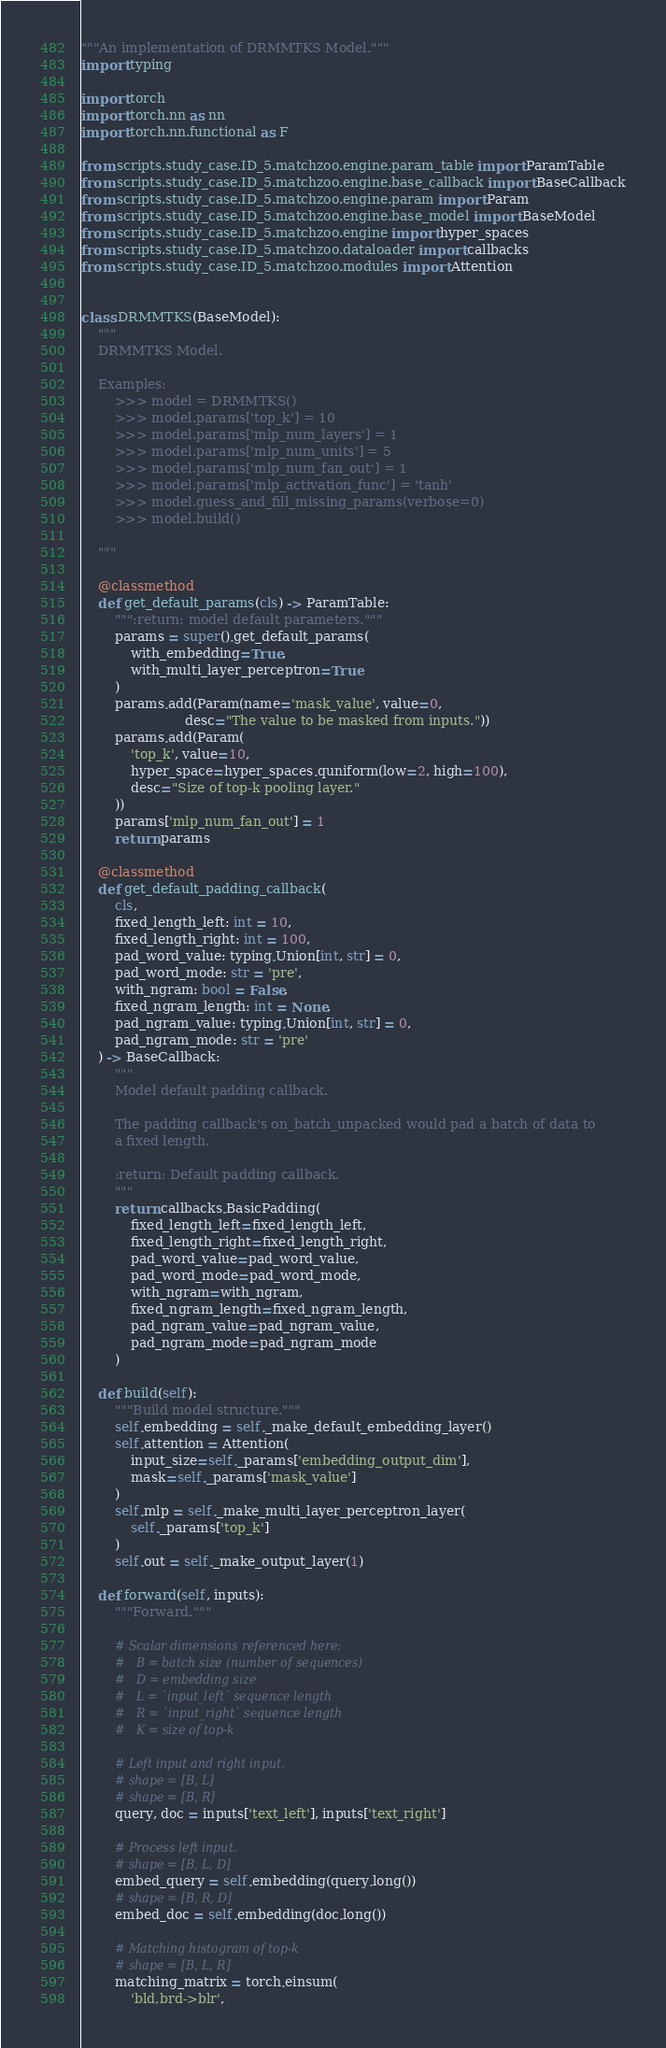Convert code to text. <code><loc_0><loc_0><loc_500><loc_500><_Python_>"""An implementation of DRMMTKS Model."""
import typing

import torch
import torch.nn as nn
import torch.nn.functional as F

from scripts.study_case.ID_5.matchzoo.engine.param_table import ParamTable
from scripts.study_case.ID_5.matchzoo.engine.base_callback import BaseCallback
from scripts.study_case.ID_5.matchzoo.engine.param import Param
from scripts.study_case.ID_5.matchzoo.engine.base_model import BaseModel
from scripts.study_case.ID_5.matchzoo.engine import hyper_spaces
from scripts.study_case.ID_5.matchzoo.dataloader import callbacks
from scripts.study_case.ID_5.matchzoo.modules import Attention


class DRMMTKS(BaseModel):
    """
    DRMMTKS Model.

    Examples:
        >>> model = DRMMTKS()
        >>> model.params['top_k'] = 10
        >>> model.params['mlp_num_layers'] = 1
        >>> model.params['mlp_num_units'] = 5
        >>> model.params['mlp_num_fan_out'] = 1
        >>> model.params['mlp_activation_func'] = 'tanh'
        >>> model.guess_and_fill_missing_params(verbose=0)
        >>> model.build()

    """

    @classmethod
    def get_default_params(cls) -> ParamTable:
        """:return: model default parameters."""
        params = super().get_default_params(
            with_embedding=True,
            with_multi_layer_perceptron=True
        )
        params.add(Param(name='mask_value', value=0,
                         desc="The value to be masked from inputs."))
        params.add(Param(
            'top_k', value=10,
            hyper_space=hyper_spaces.quniform(low=2, high=100),
            desc="Size of top-k pooling layer."
        ))
        params['mlp_num_fan_out'] = 1
        return params

    @classmethod
    def get_default_padding_callback(
        cls,
        fixed_length_left: int = 10,
        fixed_length_right: int = 100,
        pad_word_value: typing.Union[int, str] = 0,
        pad_word_mode: str = 'pre',
        with_ngram: bool = False,
        fixed_ngram_length: int = None,
        pad_ngram_value: typing.Union[int, str] = 0,
        pad_ngram_mode: str = 'pre'
    ) -> BaseCallback:
        """
        Model default padding callback.

        The padding callback's on_batch_unpacked would pad a batch of data to
        a fixed length.

        :return: Default padding callback.
        """
        return callbacks.BasicPadding(
            fixed_length_left=fixed_length_left,
            fixed_length_right=fixed_length_right,
            pad_word_value=pad_word_value,
            pad_word_mode=pad_word_mode,
            with_ngram=with_ngram,
            fixed_ngram_length=fixed_ngram_length,
            pad_ngram_value=pad_ngram_value,
            pad_ngram_mode=pad_ngram_mode
        )

    def build(self):
        """Build model structure."""
        self.embedding = self._make_default_embedding_layer()
        self.attention = Attention(
            input_size=self._params['embedding_output_dim'],
            mask=self._params['mask_value']
        )
        self.mlp = self._make_multi_layer_perceptron_layer(
            self._params['top_k']
        )
        self.out = self._make_output_layer(1)

    def forward(self, inputs):
        """Forward."""

        # Scalar dimensions referenced here:
        #   B = batch size (number of sequences)
        #   D = embedding size
        #   L = `input_left` sequence length
        #   R = `input_right` sequence length
        #   K = size of top-k

        # Left input and right input.
        # shape = [B, L]
        # shape = [B, R]
        query, doc = inputs['text_left'], inputs['text_right']

        # Process left input.
        # shape = [B, L, D]
        embed_query = self.embedding(query.long())
        # shape = [B, R, D]
        embed_doc = self.embedding(doc.long())

        # Matching histogram of top-k
        # shape = [B, L, R]
        matching_matrix = torch.einsum(
            'bld,brd->blr',</code> 